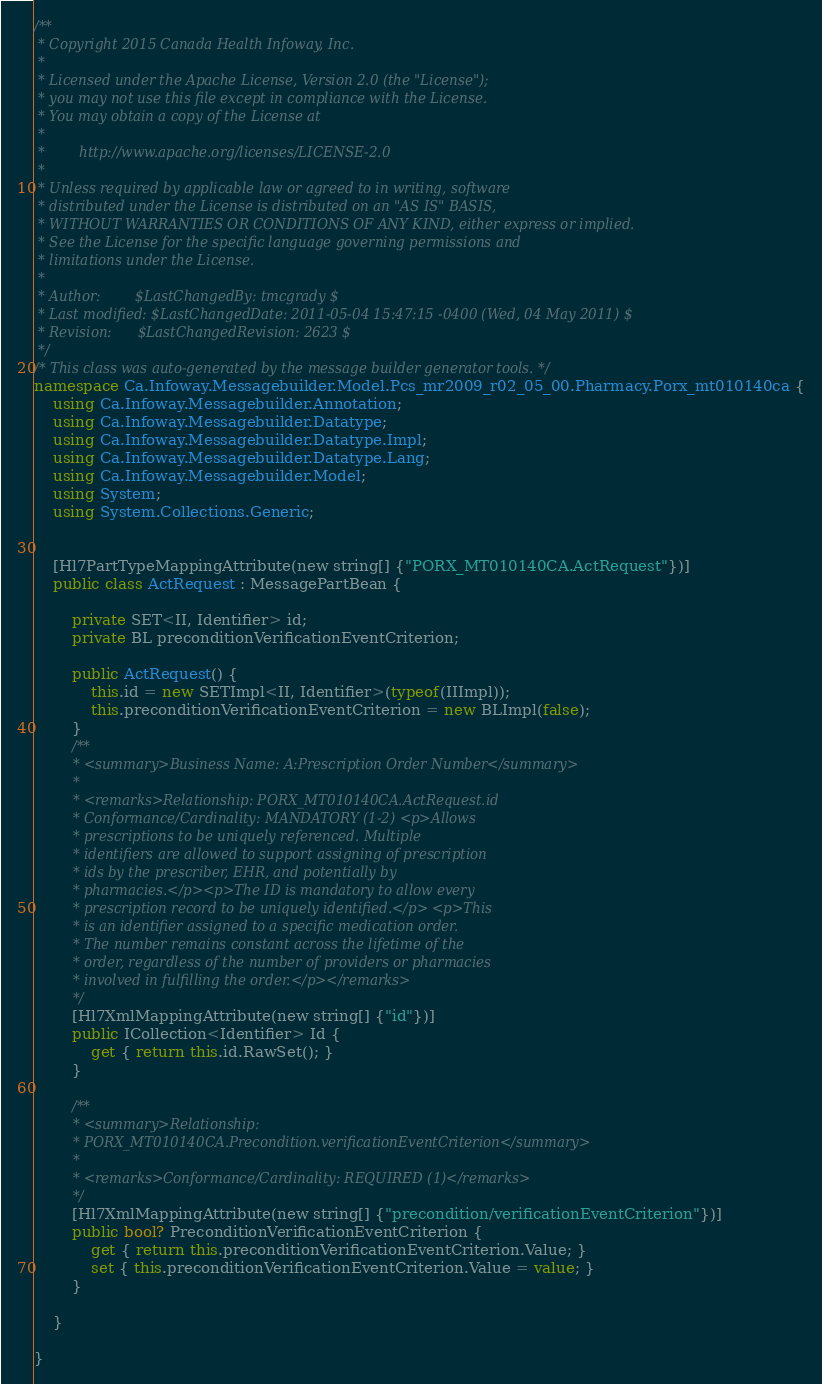Convert code to text. <code><loc_0><loc_0><loc_500><loc_500><_C#_>/**
 * Copyright 2015 Canada Health Infoway, Inc.
 *
 * Licensed under the Apache License, Version 2.0 (the "License");
 * you may not use this file except in compliance with the License.
 * You may obtain a copy of the License at
 *
 *        http://www.apache.org/licenses/LICENSE-2.0
 *
 * Unless required by applicable law or agreed to in writing, software
 * distributed under the License is distributed on an "AS IS" BASIS,
 * WITHOUT WARRANTIES OR CONDITIONS OF ANY KIND, either express or implied.
 * See the License for the specific language governing permissions and
 * limitations under the License.
 *
 * Author:        $LastChangedBy: tmcgrady $
 * Last modified: $LastChangedDate: 2011-05-04 15:47:15 -0400 (Wed, 04 May 2011) $
 * Revision:      $LastChangedRevision: 2623 $
 */
/* This class was auto-generated by the message builder generator tools. */
namespace Ca.Infoway.Messagebuilder.Model.Pcs_mr2009_r02_05_00.Pharmacy.Porx_mt010140ca {
    using Ca.Infoway.Messagebuilder.Annotation;
    using Ca.Infoway.Messagebuilder.Datatype;
    using Ca.Infoway.Messagebuilder.Datatype.Impl;
    using Ca.Infoway.Messagebuilder.Datatype.Lang;
    using Ca.Infoway.Messagebuilder.Model;
    using System;
    using System.Collections.Generic;


    [Hl7PartTypeMappingAttribute(new string[] {"PORX_MT010140CA.ActRequest"})]
    public class ActRequest : MessagePartBean {

        private SET<II, Identifier> id;
        private BL preconditionVerificationEventCriterion;

        public ActRequest() {
            this.id = new SETImpl<II, Identifier>(typeof(IIImpl));
            this.preconditionVerificationEventCriterion = new BLImpl(false);
        }
        /**
         * <summary>Business Name: A:Prescription Order Number</summary>
         * 
         * <remarks>Relationship: PORX_MT010140CA.ActRequest.id 
         * Conformance/Cardinality: MANDATORY (1-2) <p>Allows 
         * prescriptions to be uniquely referenced. Multiple 
         * identifiers are allowed to support assigning of prescription 
         * ids by the prescriber, EHR, and potentially by 
         * pharmacies.</p><p>The ID is mandatory to allow every 
         * prescription record to be uniquely identified.</p> <p>This 
         * is an identifier assigned to a specific medication order. 
         * The number remains constant across the lifetime of the 
         * order, regardless of the number of providers or pharmacies 
         * involved in fulfilling the order.</p></remarks>
         */
        [Hl7XmlMappingAttribute(new string[] {"id"})]
        public ICollection<Identifier> Id {
            get { return this.id.RawSet(); }
        }

        /**
         * <summary>Relationship: 
         * PORX_MT010140CA.Precondition.verificationEventCriterion</summary>
         * 
         * <remarks>Conformance/Cardinality: REQUIRED (1)</remarks>
         */
        [Hl7XmlMappingAttribute(new string[] {"precondition/verificationEventCriterion"})]
        public bool? PreconditionVerificationEventCriterion {
            get { return this.preconditionVerificationEventCriterion.Value; }
            set { this.preconditionVerificationEventCriterion.Value = value; }
        }

    }

}</code> 